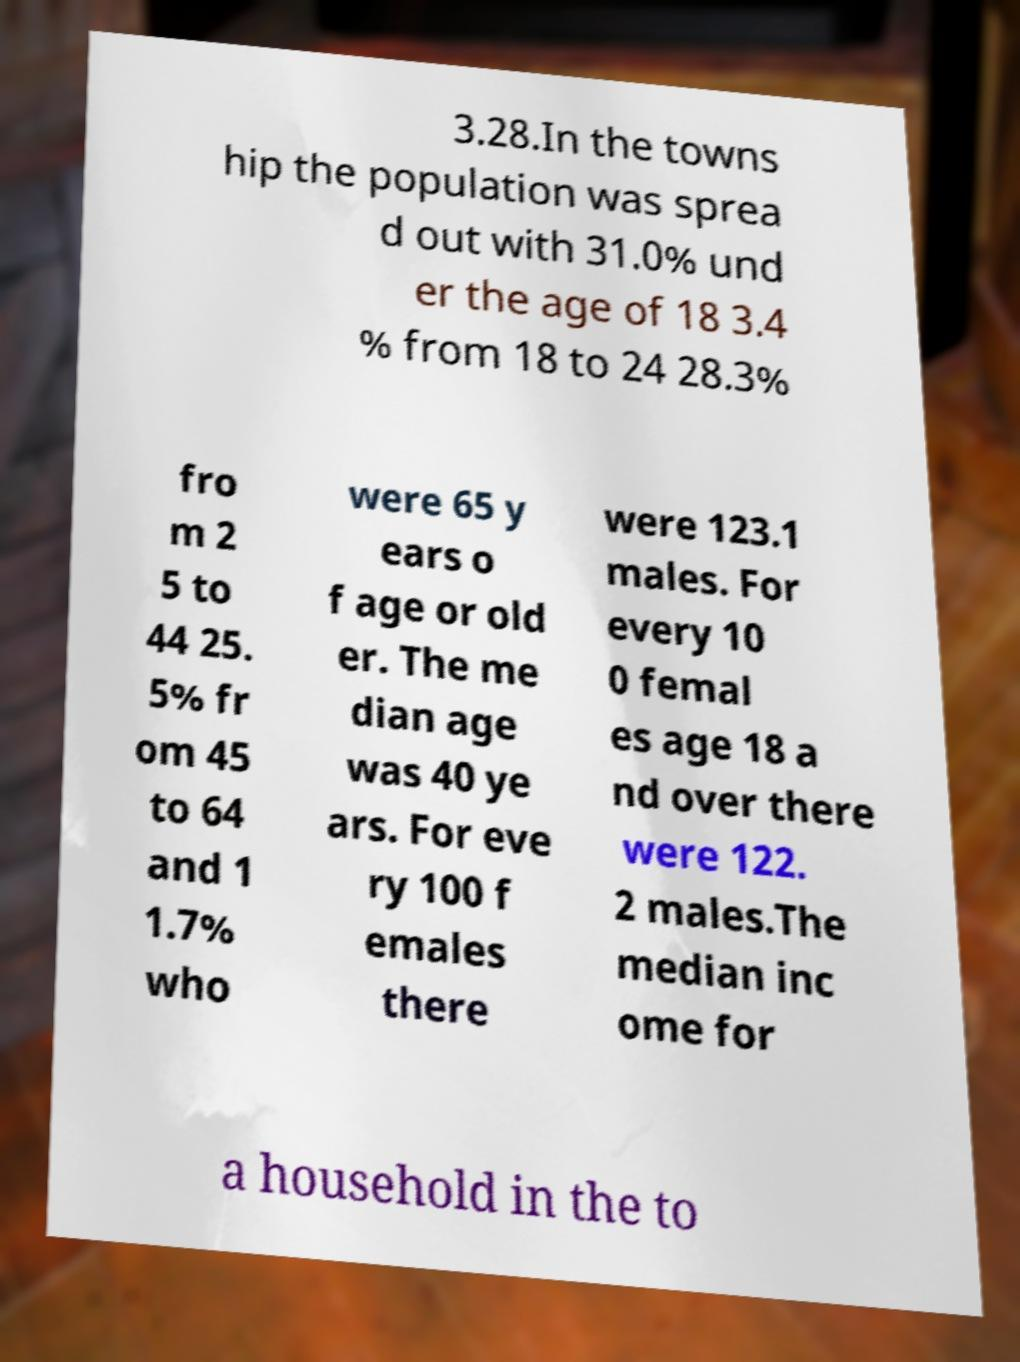I need the written content from this picture converted into text. Can you do that? 3.28.In the towns hip the population was sprea d out with 31.0% und er the age of 18 3.4 % from 18 to 24 28.3% fro m 2 5 to 44 25. 5% fr om 45 to 64 and 1 1.7% who were 65 y ears o f age or old er. The me dian age was 40 ye ars. For eve ry 100 f emales there were 123.1 males. For every 10 0 femal es age 18 a nd over there were 122. 2 males.The median inc ome for a household in the to 